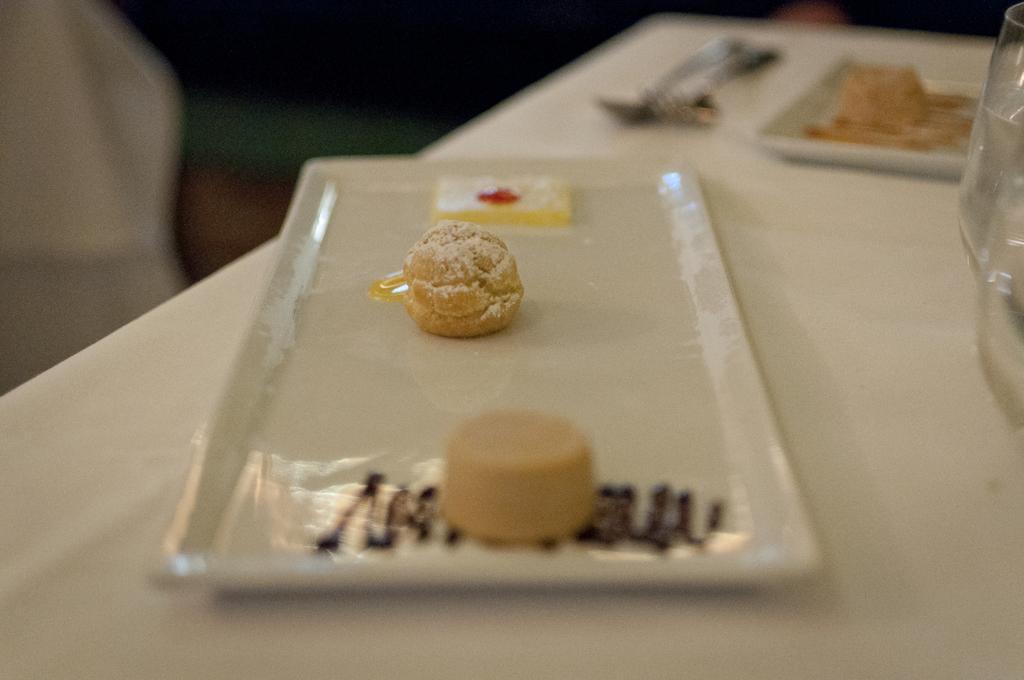Can you describe this image briefly? In this image there are food items present in the white plate on the table and on the table we can see spoons, glasses and also another plate. 